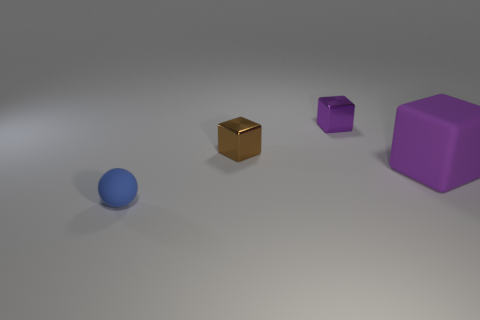The other metallic thing that is the same color as the big object is what shape?
Offer a very short reply. Cube. Is there any other thing of the same color as the big thing?
Your answer should be compact. Yes. The object that is made of the same material as the tiny purple block is what color?
Provide a succinct answer. Brown. There is a small rubber ball in front of the small purple shiny thing; what number of small brown blocks are on the right side of it?
Give a very brief answer. 1. There is a object that is both in front of the brown metal object and on the left side of the purple rubber object; what material is it?
Keep it short and to the point. Rubber. Does the purple object to the left of the big object have the same shape as the big purple rubber thing?
Provide a short and direct response. Yes. Is the number of small red cubes less than the number of tiny brown shiny things?
Offer a terse response. Yes. What number of metal blocks are the same color as the big matte cube?
Your answer should be very brief. 1. Is the color of the big block the same as the tiny shiny block that is behind the brown block?
Offer a terse response. Yes. Is the number of metallic objects greater than the number of tiny things?
Provide a short and direct response. No. 